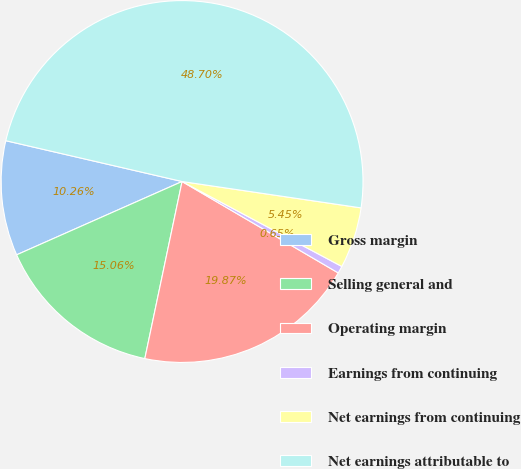Convert chart to OTSL. <chart><loc_0><loc_0><loc_500><loc_500><pie_chart><fcel>Gross margin<fcel>Selling general and<fcel>Operating margin<fcel>Earnings from continuing<fcel>Net earnings from continuing<fcel>Net earnings attributable to<nl><fcel>10.26%<fcel>15.06%<fcel>19.87%<fcel>0.65%<fcel>5.45%<fcel>48.7%<nl></chart> 